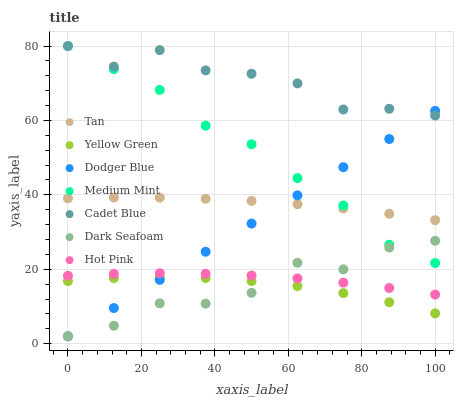Does Dark Seafoam have the minimum area under the curve?
Answer yes or no. Yes. Does Cadet Blue have the maximum area under the curve?
Answer yes or no. Yes. Does Yellow Green have the minimum area under the curve?
Answer yes or no. No. Does Yellow Green have the maximum area under the curve?
Answer yes or no. No. Is Dodger Blue the smoothest?
Answer yes or no. Yes. Is Cadet Blue the roughest?
Answer yes or no. Yes. Is Yellow Green the smoothest?
Answer yes or no. No. Is Yellow Green the roughest?
Answer yes or no. No. Does Dark Seafoam have the lowest value?
Answer yes or no. Yes. Does Yellow Green have the lowest value?
Answer yes or no. No. Does Cadet Blue have the highest value?
Answer yes or no. Yes. Does Yellow Green have the highest value?
Answer yes or no. No. Is Yellow Green less than Medium Mint?
Answer yes or no. Yes. Is Tan greater than Yellow Green?
Answer yes or no. Yes. Does Dodger Blue intersect Tan?
Answer yes or no. Yes. Is Dodger Blue less than Tan?
Answer yes or no. No. Is Dodger Blue greater than Tan?
Answer yes or no. No. Does Yellow Green intersect Medium Mint?
Answer yes or no. No. 